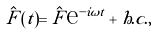<formula> <loc_0><loc_0><loc_500><loc_500>\hat { F } ( t ) = \hat { F } \text {e} ^ { - i \omega t } + h . c . ,</formula> 